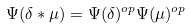<formula> <loc_0><loc_0><loc_500><loc_500>\Psi ( \delta * \mu ) = \Psi ( \delta ) ^ { o p } \Psi ( \mu ) ^ { o p }</formula> 